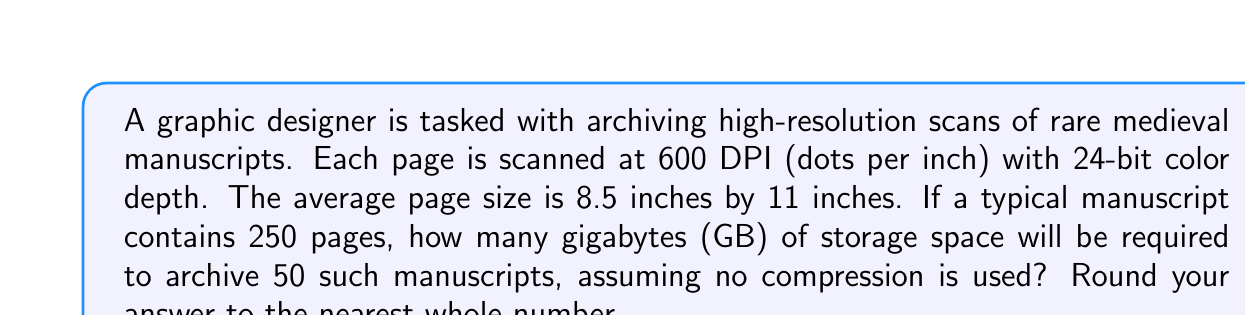What is the answer to this math problem? Let's break this down step-by-step:

1. Calculate the number of pixels per page:
   $$ \text{Width in pixels} = 8.5 \text{ inches} \times 600 \text{ DPI} = 5100 \text{ pixels} $$
   $$ \text{Height in pixels} = 11 \text{ inches} \times 600 \text{ DPI} = 6600 \text{ pixels} $$
   $$ \text{Pixels per page} = 5100 \times 6600 = 33,660,000 \text{ pixels} $$

2. Calculate the number of bits per page:
   $$ \text{Bits per page} = 33,660,000 \text{ pixels} \times 24 \text{ bits/pixel} = 807,840,000 \text{ bits} $$

3. Convert bits to bytes:
   $$ \text{Bytes per page} = 807,840,000 \text{ bits} \div 8 \text{ bits/byte} = 100,980,000 \text{ bytes} $$

4. Calculate the storage for one manuscript (250 pages):
   $$ \text{Bytes per manuscript} = 100,980,000 \text{ bytes} \times 250 \text{ pages} = 25,245,000,000 \text{ bytes} $$

5. Calculate the storage for 50 manuscripts:
   $$ \text{Total bytes} = 25,245,000,000 \text{ bytes} \times 50 = 1,262,250,000,000 \text{ bytes} $$

6. Convert bytes to gigabytes:
   $$ \text{Gigabytes} = \frac{1,262,250,000,000 \text{ bytes}}{1,000,000,000 \text{ bytes/GB}} = 1262.25 \text{ GB} $$

7. Round to the nearest whole number:
   $$ 1262.25 \text{ GB} \approx 1262 \text{ GB} $$
Answer: 1262 GB 